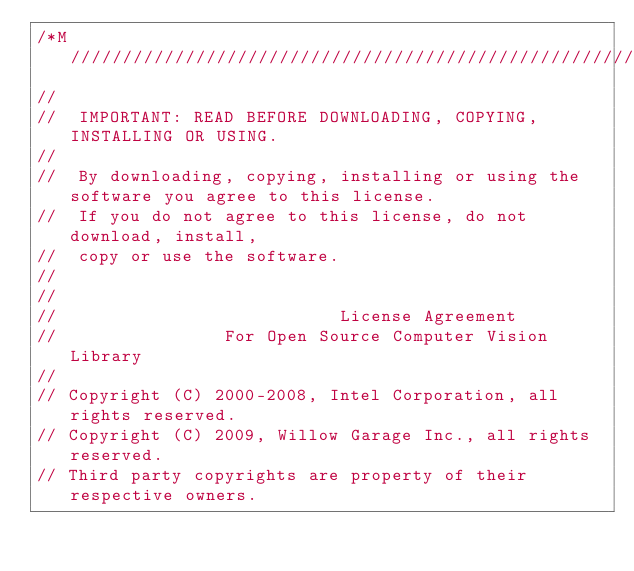<code> <loc_0><loc_0><loc_500><loc_500><_Cuda_>/*M///////////////////////////////////////////////////////////////////////////////////////
//
//  IMPORTANT: READ BEFORE DOWNLOADING, COPYING, INSTALLING OR USING.
//
//  By downloading, copying, installing or using the software you agree to this license.
//  If you do not agree to this license, do not download, install,
//  copy or use the software.
//
//
//                           License Agreement
//                For Open Source Computer Vision Library
//
// Copyright (C) 2000-2008, Intel Corporation, all rights reserved.
// Copyright (C) 2009, Willow Garage Inc., all rights reserved.
// Third party copyrights are property of their respective owners.</code> 